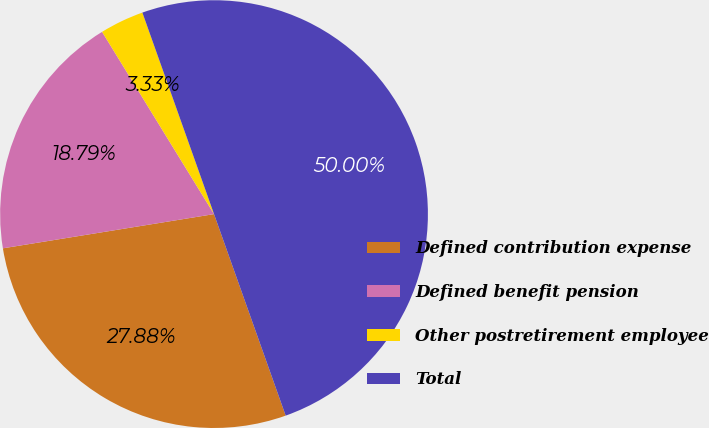Convert chart. <chart><loc_0><loc_0><loc_500><loc_500><pie_chart><fcel>Defined contribution expense<fcel>Defined benefit pension<fcel>Other postretirement employee<fcel>Total<nl><fcel>27.88%<fcel>18.79%<fcel>3.33%<fcel>50.0%<nl></chart> 